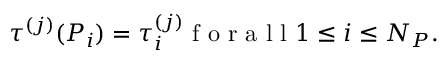<formula> <loc_0><loc_0><loc_500><loc_500>\tau ^ { ( j ) } ( P _ { i } ) = \tau _ { i } ^ { ( j ) } f o r a l l 1 \leq i \leq N _ { P } .</formula> 